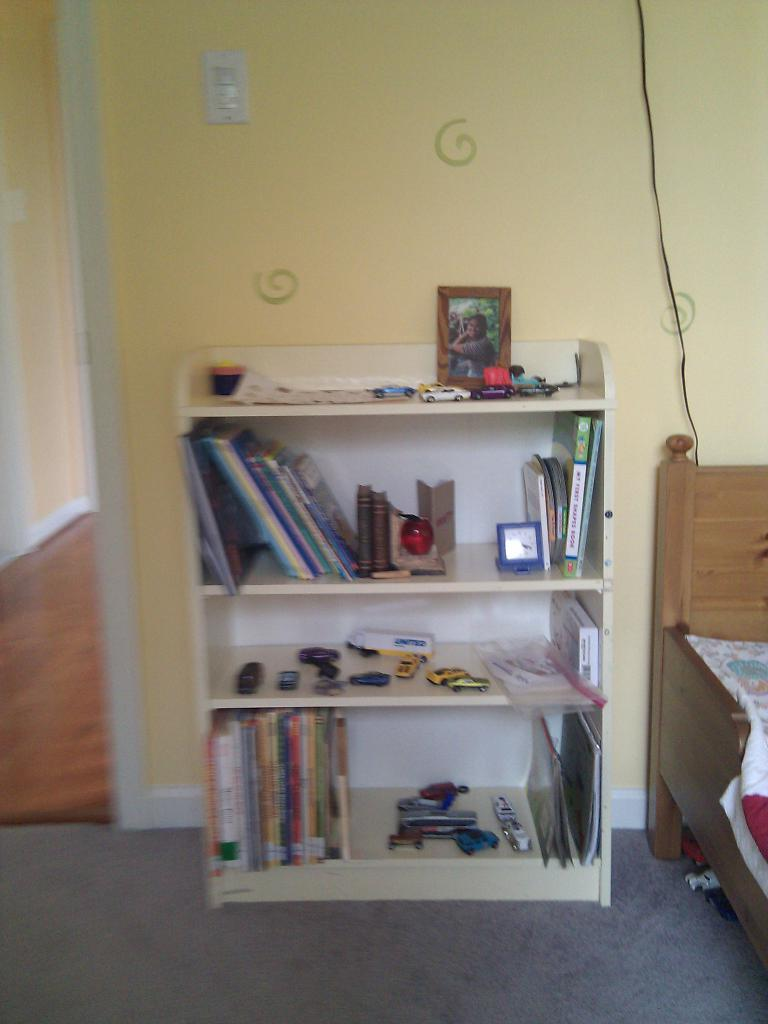What is located in the center of the image? There is a shelf in the center of the image. What items can be found on the shelf? The shelf contains a book, a clock, a phone, toys, and tools. What is on the right side of the image? There is a bed on the right side of the image. What can be seen in the background of the image? There is a wall in the background of the image. How many legs can be seen on the snakes in the image? There are no snakes present in the image, so it is not possible to determine the number of legs on any snakes. 